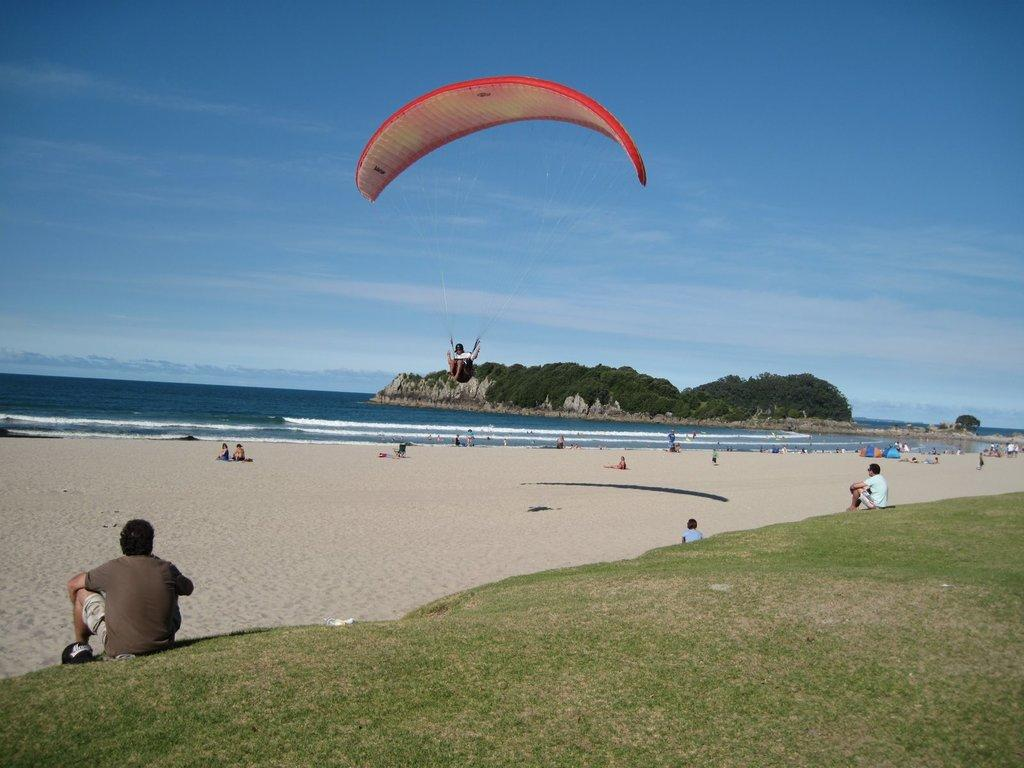What type of natural environment is visible in the image? There is grass, trees, and water visible in the image, which suggests a natural environment. Can you describe the people in the image? There are people in the image, but their specific actions or appearances are not mentioned in the facts. What is the weather like in the image? The sky is cloudy in the image, which suggests a potentially overcast or rainy day. What is the person paragliding doing in the image? The person paragliding is flying through the air in the image. What type of slave is depicted in the image? There is no mention of a slave or any form of slavery in the image or the provided facts. What type of vessel is being used by the people in the image? There is no mention of a vessel or any form of transportation in the image or the provided facts. 